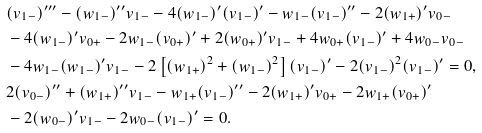<formula> <loc_0><loc_0><loc_500><loc_500>& ( v _ { 1 - } ) ^ { \prime \prime \prime } - ( w _ { 1 - } ) ^ { \prime \prime } v _ { 1 - } - 4 ( w _ { 1 - } ) ^ { \prime } ( v _ { 1 - } ) ^ { \prime } - w _ { 1 - } ( v _ { 1 - } ) ^ { \prime \prime } - 2 ( w _ { 1 + } ) ^ { \prime } v _ { 0 - } \\ & - 4 ( w _ { 1 - } ) ^ { \prime } v _ { 0 + } - 2 w _ { 1 - } ( v _ { 0 + } ) ^ { \prime } + 2 ( w _ { 0 + } ) ^ { \prime } v _ { 1 - } + 4 w _ { 0 + } ( v _ { 1 - } ) ^ { \prime } + 4 w _ { 0 - } v _ { 0 - } \\ & - 4 w _ { 1 - } ( w _ { 1 - } ) ^ { \prime } v _ { 1 - } - 2 \left [ ( w _ { 1 + } ) ^ { 2 } + ( w _ { 1 - } ) ^ { 2 } \right ] ( v _ { 1 - } ) ^ { \prime } - 2 ( v _ { 1 - } ) ^ { 2 } ( v _ { 1 - } ) ^ { \prime } = 0 , \\ & 2 ( v _ { 0 - } ) ^ { \prime \prime } + ( w _ { 1 + } ) ^ { \prime \prime } v _ { 1 - } - w _ { 1 + } ( v _ { 1 - } ) ^ { \prime \prime } - 2 ( w _ { 1 + } ) ^ { \prime } v _ { 0 + } - 2 w _ { 1 + } ( v _ { 0 + } ) ^ { \prime } \\ & - 2 ( w _ { 0 - } ) ^ { \prime } v _ { 1 - } - 2 w _ { 0 - } ( v _ { 1 - } ) ^ { \prime } = 0 .</formula> 